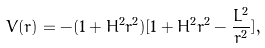Convert formula to latex. <formula><loc_0><loc_0><loc_500><loc_500>V ( r ) = - ( 1 + H ^ { 2 } r ^ { 2 } ) [ 1 + H ^ { 2 } r ^ { 2 } - \frac { L ^ { 2 } } { r ^ { 2 } } ] ,</formula> 